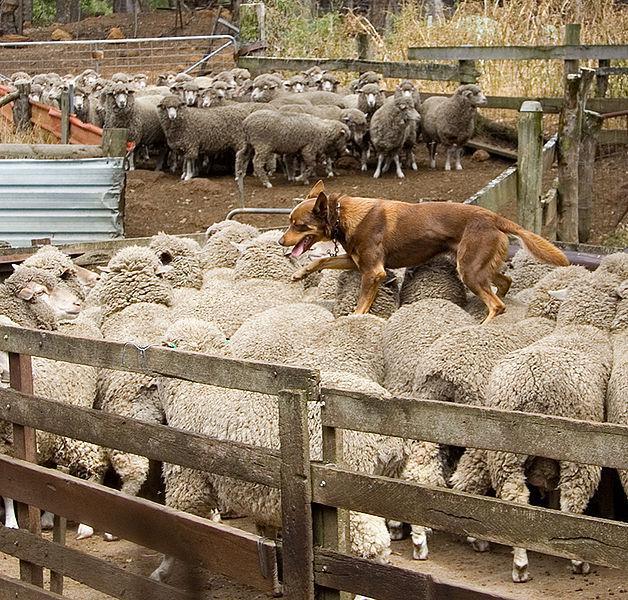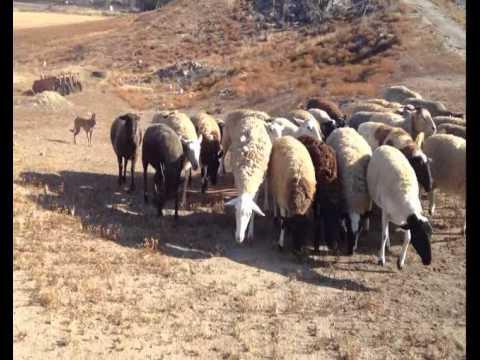The first image is the image on the left, the second image is the image on the right. For the images shown, is this caption "In one image, no livestock are present but at least one dog is visible." true? Answer yes or no. No. The first image is the image on the left, the second image is the image on the right. Given the left and right images, does the statement "All images show a dog with sheep." hold true? Answer yes or no. Yes. 